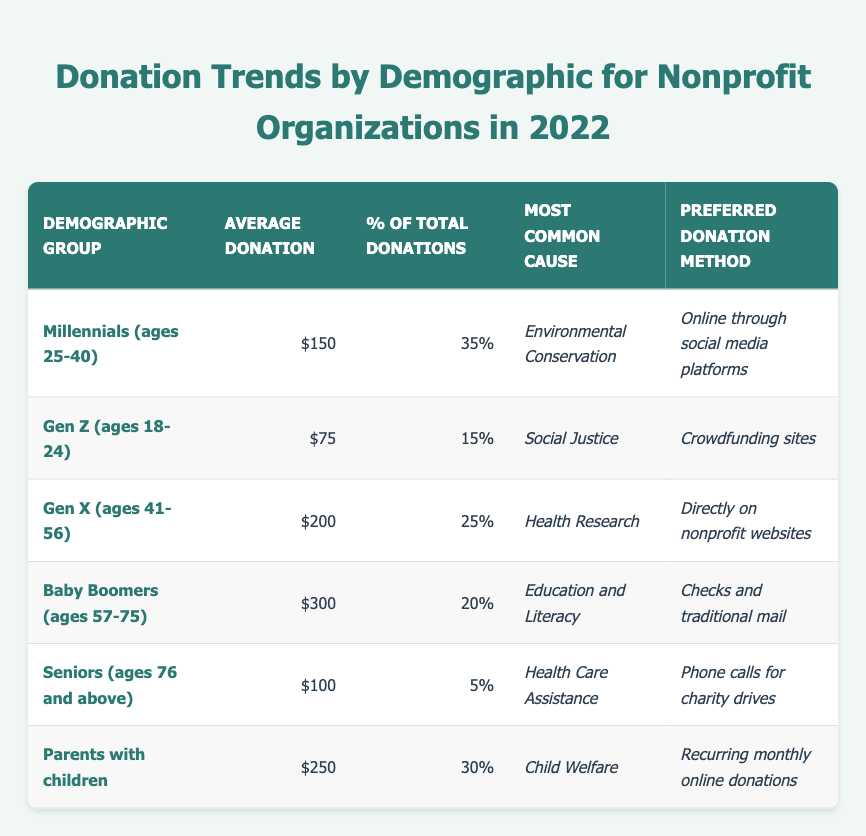What is the average donation amount from Baby Boomers? According to the table, the average donation amount from the Baby Boomers demographic group is stated directly under the "Average Donation" column, which shows $300.
Answer: $300 Which demographic group has the smallest percentage of total donations? By examining the table, the "Percentage of Total Donations" column shows that Seniors (ages 76 and above) have the smallest percentage at 5%.
Answer: 5% What is the most common cause for donations among Gen Z? The "Most Common Cause" column indicates that for the Gen Z demographic, the most common cause is Social Justice.
Answer: Social Justice Who contributes the highest average donation? Looking at the "Average Donation" column, Baby Boomers have the highest average donation at $300 compared to other groups.
Answer: Baby Boomers How much do Parents with children donate on average compared to Millennials? The average donation for Parents with children is $250 and for Millennials, it is $150. To compare, $250 - $150 = $100, showing Parents with children donate $100 more on average.
Answer: Parents with children donate $100 more What percentage of total donations come from Gen X and Baby Boomers combined? The total percentage contribution from both groups can be calculated by summing their individual percentages: Gen X (25%) + Baby Boomers (20%) = 45%.
Answer: 45% Is the average donation from Seniors more than that of Gen Z? By checking the "Average Donation" column, Seniors have an average of $100 while Gen Z has $75. Therefore, $100 is greater than $75, confirming this statement is true.
Answer: Yes Which demographic prefers recurring monthly online donations? The table in the "Preferred Donation Method" column states that Parents with children prefer recurring monthly online donations specifically.
Answer: Parents with children What is the average donation for the three youngest demographic groups combined? The average donations for the three youngest groups are: Millennials ($150), Gen Z ($75), and Parents with children ($250). The total is $150 + $75 + $250 = $475. Dividing by 3 gives an average of $158.33, rounded to two decimal places.
Answer: $158.33 Which demographic has the same average donation as the percentage of total donations from Seniors? The average donation amount from Seniors is $100, while the percentage of total donations is also 5%, which does not match. The closest average donation (100) does not correspond with the given percentages for the other groups.
Answer: None 